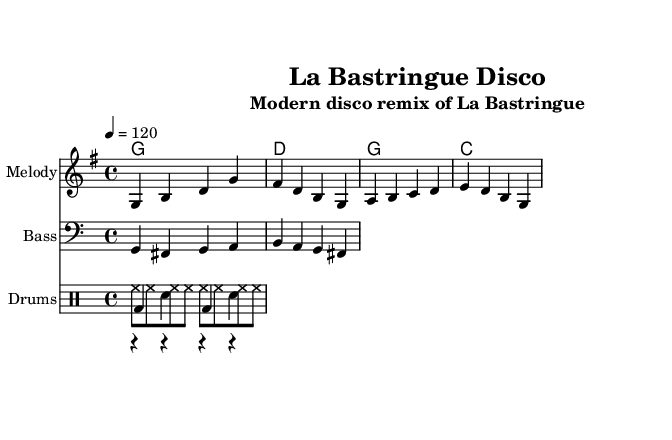What is the key signature of this music? The key signature is G major, which has one sharp (F#). I can determine this by looking at the key signature indicated at the beginning of the piece while considering the context of the melody and harmony provided.
Answer: G major What is the time signature of this piece? The time signature is four-four, which is represented by the 4/4 notation at the beginning of the score. This means there are four beats in each measure, and the quarter note receives one beat.
Answer: 4/4 What is the tempo marking for this music? The tempo marking is quarter note equals 120 beats per minute, indicated at the beginning of the score. This tells us the speed at which the music should be played.
Answer: 120 How many measures are in the melody? The melody consists of four measures as indicated by the number of distinct groupings of notes within the provided staff. Each measure is separated by vertical bar lines.
Answer: 4 Which drum elements are used in this remix? The remix includes hi-hats, claps, and a kick drum, as seen in the drum staff where each of these components is clearly notated. Each element has its own notation in the drum lines.
Answer: Hi-hats, claps, kick drum What chord is played in the first measure? The chord in the first measure is G major, which can be deduced from the chord names being notated above the staff, corresponding to the melody.
Answer: G What type of music genre does this piece represent? This piece represents disco music, as indicated in the title and the rhythmic elements employed in the drum part. Disco typically incorporates upbeat rhythms and synthesizer sounds, which are evident in this arrangement.
Answer: Disco 